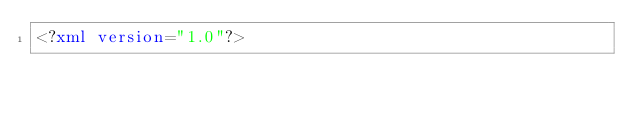Convert code to text. <code><loc_0><loc_0><loc_500><loc_500><_XML_><?xml version="1.0"?></code> 